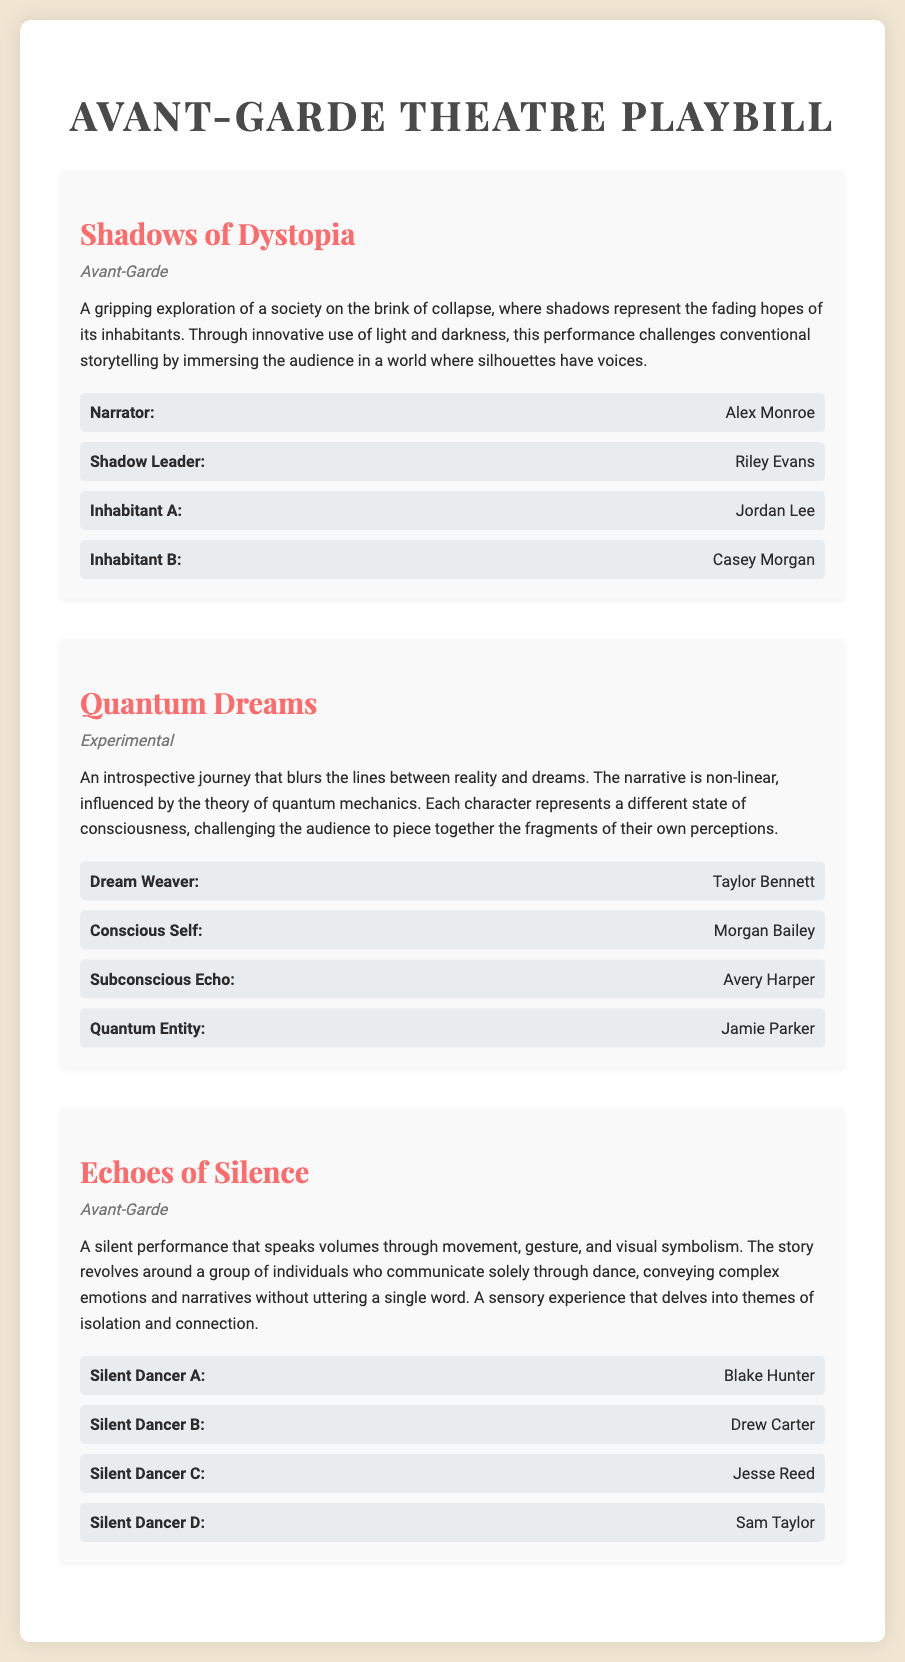What is the title of the first performance listed? The title of the first performance is the first h2 element, which is "Shadows of Dystopia."
Answer: Shadows of Dystopia How many cast members are in "Quantum Dreams"? The cast section for "Quantum Dreams" lists four distinct cast members.
Answer: 4 Who plays the role of "Silent Dancer A" in "Echoes of Silence"? The role of "Silent Dancer A" is held by Blake Hunter, as indicated in the cast section.
Answer: Blake Hunter What genre does "Shadows of Dystopia" belong to? The genre is specified in the genre section directly below the title.
Answer: Avant-Garde Which performance has a non-linear narrative influenced by quantum mechanics? The performance described with a non-linear narrative due to quantum mechanics is mentioned in its synopsis.
Answer: Quantum Dreams What is a key theme explored in "Echoes of Silence"? Themes are discussed directly in the synopsis, which mentions isolation and connection.
Answer: Isolation and connection Who is the actor playing the "Shadow Leader"? The actor for "Shadow Leader" is specifically listed in the cast section for "Shadows of Dystopia."
Answer: Riley Evans What type of experience does "Echoes of Silence" aim to provide? The synopsis of "Echoes of Silence" describes it as a sensory experience.
Answer: Sensory experience 